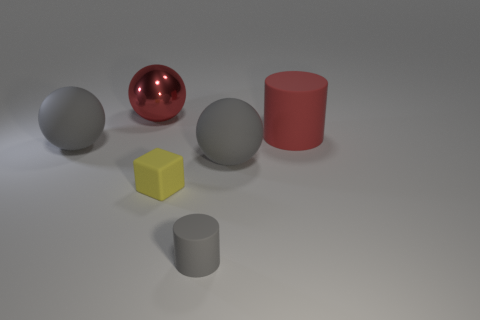Is there any other thing that has the same material as the red ball?
Provide a short and direct response. No. Are there an equal number of gray cylinders that are to the right of the big red cylinder and big cyan metallic cylinders?
Offer a terse response. Yes. There is a ball right of the small yellow cube; what is its size?
Offer a very short reply. Large. How many large things are yellow matte spheres or red metal spheres?
Offer a very short reply. 1. There is a small object that is the same shape as the big red matte object; what color is it?
Provide a short and direct response. Gray. Do the shiny sphere and the gray rubber cylinder have the same size?
Your response must be concise. No. What number of things are either big green rubber spheres or rubber objects behind the yellow object?
Your answer should be very brief. 3. What color is the large rubber object that is in front of the large gray matte ball on the left side of the small gray rubber cylinder?
Give a very brief answer. Gray. There is a rubber ball to the right of the large metallic ball; is its color the same as the tiny cylinder?
Keep it short and to the point. Yes. There is a big gray sphere left of the large metallic sphere; what is it made of?
Offer a terse response. Rubber. 